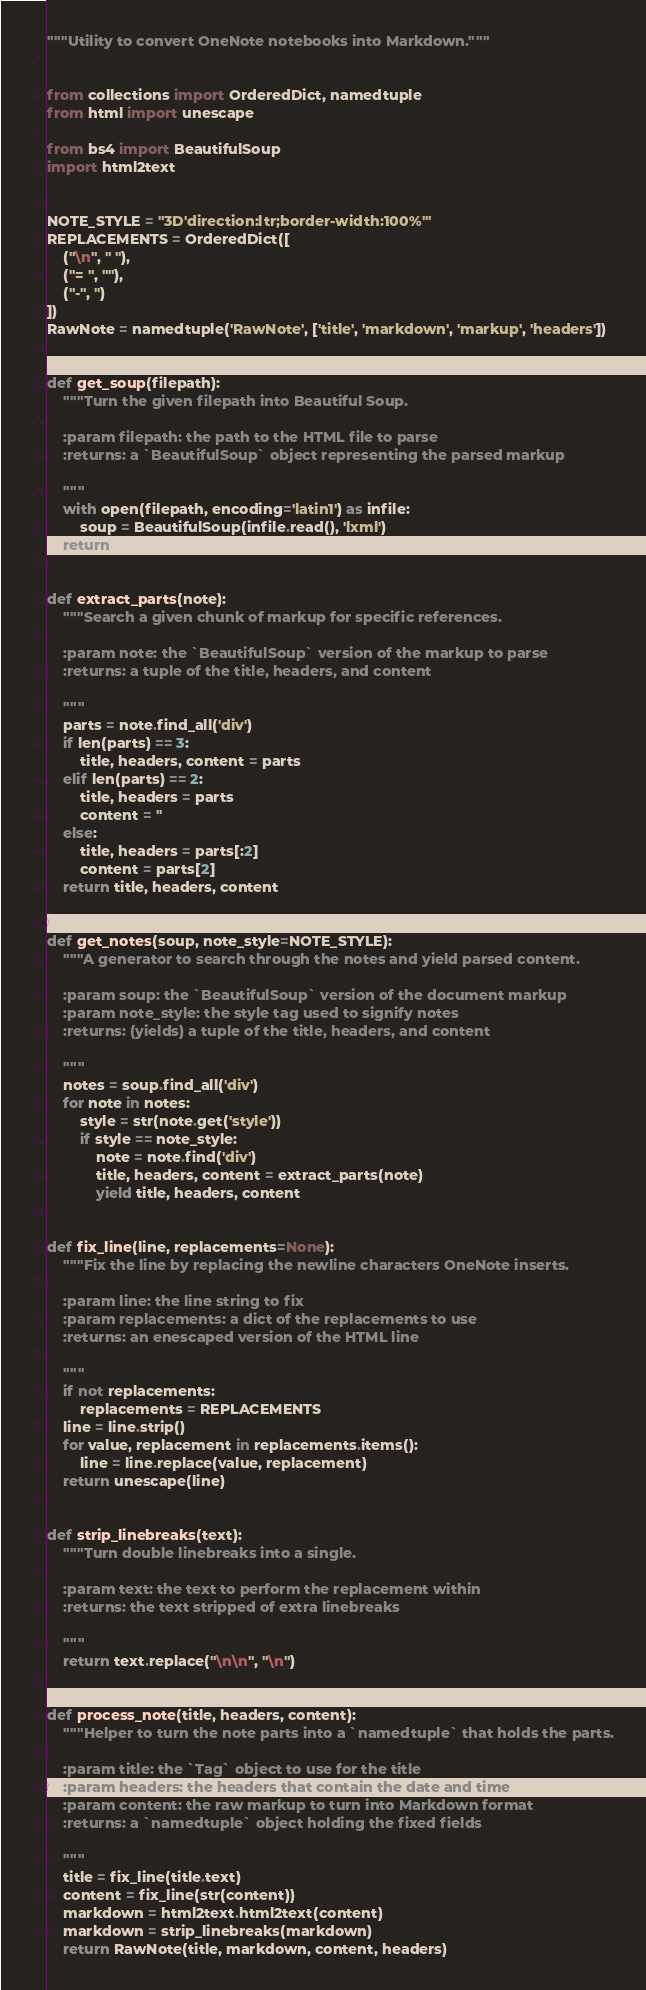<code> <loc_0><loc_0><loc_500><loc_500><_Python_>"""Utility to convert OneNote notebooks into Markdown."""


from collections import OrderedDict, namedtuple
from html import unescape

from bs4 import BeautifulSoup
import html2text


NOTE_STYLE = "3D'direction:ltr;border-width:100%'"
REPLACEMENTS = OrderedDict([
    ("\n", " "),
    ("= ", ""),
    ("-", '')
])
RawNote = namedtuple('RawNote', ['title', 'markdown', 'markup', 'headers'])


def get_soup(filepath):
    """Turn the given filepath into Beautiful Soup.

    :param filepath: the path to the HTML file to parse
    :returns: a `BeautifulSoup` object representing the parsed markup

    """
    with open(filepath, encoding='latin1') as infile:
        soup = BeautifulSoup(infile.read(), 'lxml')
    return soup


def extract_parts(note):
    """Search a given chunk of markup for specific references.

    :param note: the `BeautifulSoup` version of the markup to parse
    :returns: a tuple of the title, headers, and content

    """
    parts = note.find_all('div')
    if len(parts) == 3:
        title, headers, content = parts
    elif len(parts) == 2:
        title, headers = parts
        content = ''
    else:
        title, headers = parts[:2]
        content = parts[2]
    return title, headers, content


def get_notes(soup, note_style=NOTE_STYLE):
    """A generator to search through the notes and yield parsed content.

    :param soup: the `BeautifulSoup` version of the document markup
    :param note_style: the style tag used to signify notes
    :returns: (yields) a tuple of the title, headers, and content

    """
    notes = soup.find_all('div')
    for note in notes:
        style = str(note.get('style'))
        if style == note_style:
            note = note.find('div')
            title, headers, content = extract_parts(note)
            yield title, headers, content


def fix_line(line, replacements=None):
    """Fix the line by replacing the newline characters OneNote inserts.

    :param line: the line string to fix
    :param replacements: a dict of the replacements to use
    :returns: an enescaped version of the HTML line

    """
    if not replacements:
        replacements = REPLACEMENTS
    line = line.strip()
    for value, replacement in replacements.items():
        line = line.replace(value, replacement)
    return unescape(line)


def strip_linebreaks(text):
    """Turn double linebreaks into a single.

    :param text: the text to perform the replacement within
    :returns: the text stripped of extra linebreaks

    """
    return text.replace("\n\n", "\n")


def process_note(title, headers, content):
    """Helper to turn the note parts into a `namedtuple` that holds the parts.

    :param title: the `Tag` object to use for the title
    :param headers: the headers that contain the date and time
    :param content: the raw markup to turn into Markdown format
    :returns: a `namedtuple` object holding the fixed fields

    """
    title = fix_line(title.text)
    content = fix_line(str(content))
    markdown = html2text.html2text(content)
    markdown = strip_linebreaks(markdown)
    return RawNote(title, markdown, content, headers)
</code> 